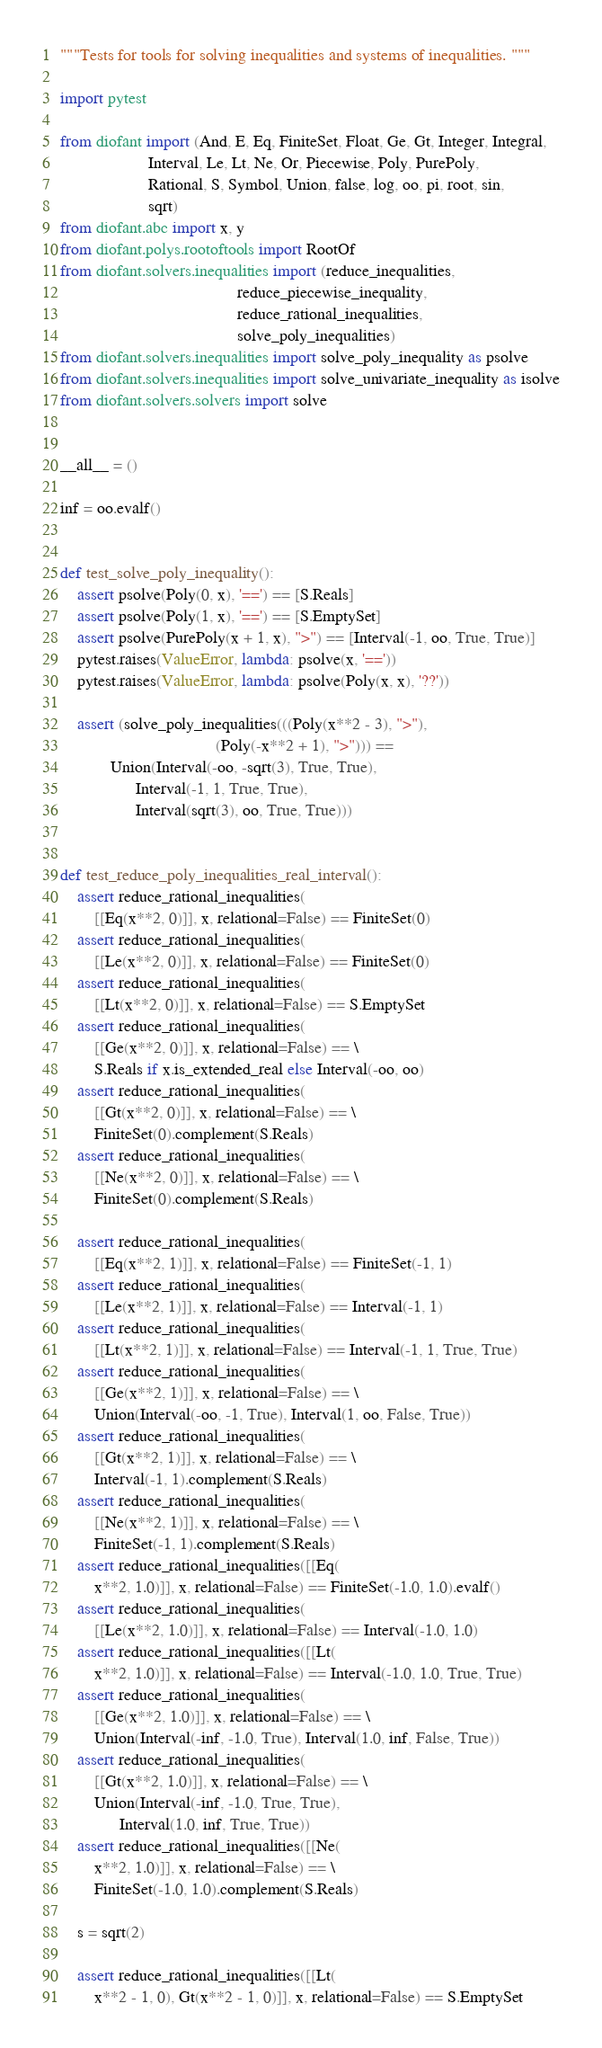<code> <loc_0><loc_0><loc_500><loc_500><_Python_>"""Tests for tools for solving inequalities and systems of inequalities. """

import pytest

from diofant import (And, E, Eq, FiniteSet, Float, Ge, Gt, Integer, Integral,
                     Interval, Le, Lt, Ne, Or, Piecewise, Poly, PurePoly,
                     Rational, S, Symbol, Union, false, log, oo, pi, root, sin,
                     sqrt)
from diofant.abc import x, y
from diofant.polys.rootoftools import RootOf
from diofant.solvers.inequalities import (reduce_inequalities,
                                          reduce_piecewise_inequality,
                                          reduce_rational_inequalities,
                                          solve_poly_inequalities)
from diofant.solvers.inequalities import solve_poly_inequality as psolve
from diofant.solvers.inequalities import solve_univariate_inequality as isolve
from diofant.solvers.solvers import solve


__all__ = ()

inf = oo.evalf()


def test_solve_poly_inequality():
    assert psolve(Poly(0, x), '==') == [S.Reals]
    assert psolve(Poly(1, x), '==') == [S.EmptySet]
    assert psolve(PurePoly(x + 1, x), ">") == [Interval(-1, oo, True, True)]
    pytest.raises(ValueError, lambda: psolve(x, '=='))
    pytest.raises(ValueError, lambda: psolve(Poly(x, x), '??'))

    assert (solve_poly_inequalities(((Poly(x**2 - 3), ">"),
                                     (Poly(-x**2 + 1), ">"))) ==
            Union(Interval(-oo, -sqrt(3), True, True),
                  Interval(-1, 1, True, True),
                  Interval(sqrt(3), oo, True, True)))


def test_reduce_poly_inequalities_real_interval():
    assert reduce_rational_inequalities(
        [[Eq(x**2, 0)]], x, relational=False) == FiniteSet(0)
    assert reduce_rational_inequalities(
        [[Le(x**2, 0)]], x, relational=False) == FiniteSet(0)
    assert reduce_rational_inequalities(
        [[Lt(x**2, 0)]], x, relational=False) == S.EmptySet
    assert reduce_rational_inequalities(
        [[Ge(x**2, 0)]], x, relational=False) == \
        S.Reals if x.is_extended_real else Interval(-oo, oo)
    assert reduce_rational_inequalities(
        [[Gt(x**2, 0)]], x, relational=False) == \
        FiniteSet(0).complement(S.Reals)
    assert reduce_rational_inequalities(
        [[Ne(x**2, 0)]], x, relational=False) == \
        FiniteSet(0).complement(S.Reals)

    assert reduce_rational_inequalities(
        [[Eq(x**2, 1)]], x, relational=False) == FiniteSet(-1, 1)
    assert reduce_rational_inequalities(
        [[Le(x**2, 1)]], x, relational=False) == Interval(-1, 1)
    assert reduce_rational_inequalities(
        [[Lt(x**2, 1)]], x, relational=False) == Interval(-1, 1, True, True)
    assert reduce_rational_inequalities(
        [[Ge(x**2, 1)]], x, relational=False) == \
        Union(Interval(-oo, -1, True), Interval(1, oo, False, True))
    assert reduce_rational_inequalities(
        [[Gt(x**2, 1)]], x, relational=False) == \
        Interval(-1, 1).complement(S.Reals)
    assert reduce_rational_inequalities(
        [[Ne(x**2, 1)]], x, relational=False) == \
        FiniteSet(-1, 1).complement(S.Reals)
    assert reduce_rational_inequalities([[Eq(
        x**2, 1.0)]], x, relational=False) == FiniteSet(-1.0, 1.0).evalf()
    assert reduce_rational_inequalities(
        [[Le(x**2, 1.0)]], x, relational=False) == Interval(-1.0, 1.0)
    assert reduce_rational_inequalities([[Lt(
        x**2, 1.0)]], x, relational=False) == Interval(-1.0, 1.0, True, True)
    assert reduce_rational_inequalities(
        [[Ge(x**2, 1.0)]], x, relational=False) == \
        Union(Interval(-inf, -1.0, True), Interval(1.0, inf, False, True))
    assert reduce_rational_inequalities(
        [[Gt(x**2, 1.0)]], x, relational=False) == \
        Union(Interval(-inf, -1.0, True, True),
              Interval(1.0, inf, True, True))
    assert reduce_rational_inequalities([[Ne(
        x**2, 1.0)]], x, relational=False) == \
        FiniteSet(-1.0, 1.0).complement(S.Reals)

    s = sqrt(2)

    assert reduce_rational_inequalities([[Lt(
        x**2 - 1, 0), Gt(x**2 - 1, 0)]], x, relational=False) == S.EmptySet</code> 